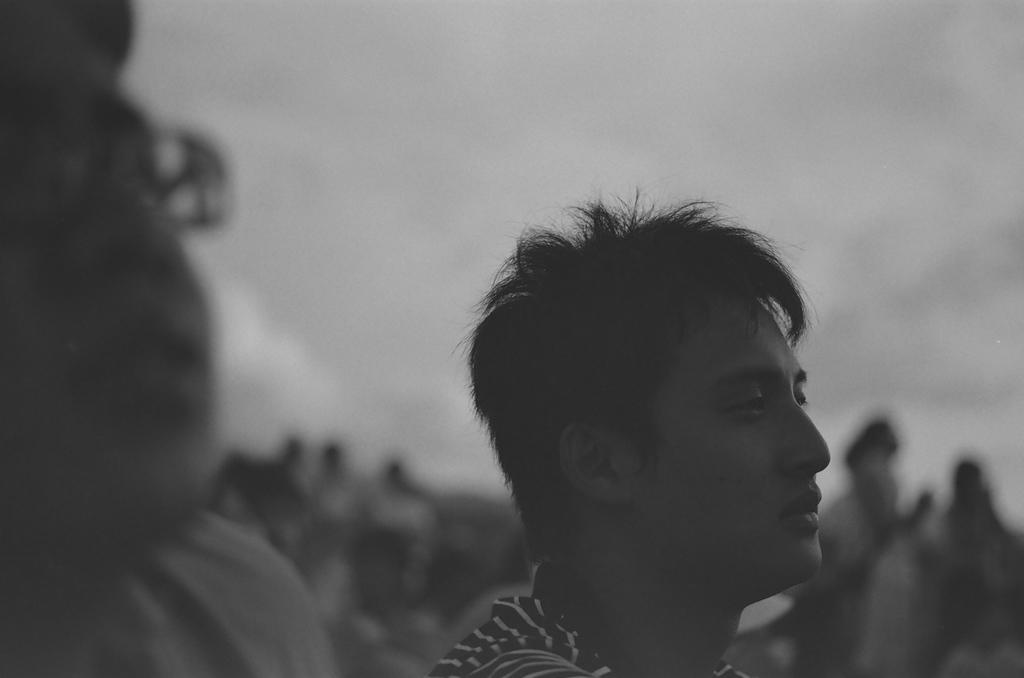Describe this image in one or two sentences. In this image I can see two persons, background I can see few other persons standing. The image is in black and white. 